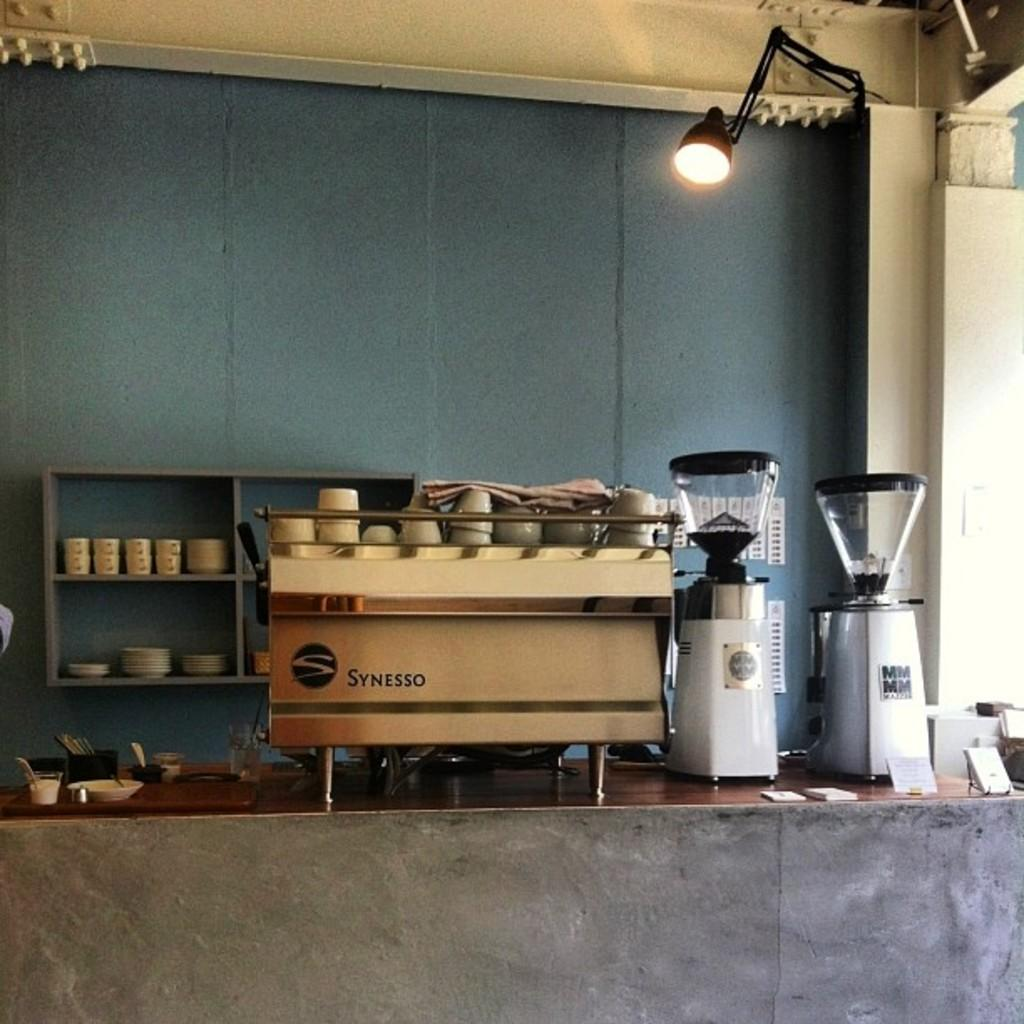<image>
Give a short and clear explanation of the subsequent image. A counter holding many coffee making items including a Synesso machine. 